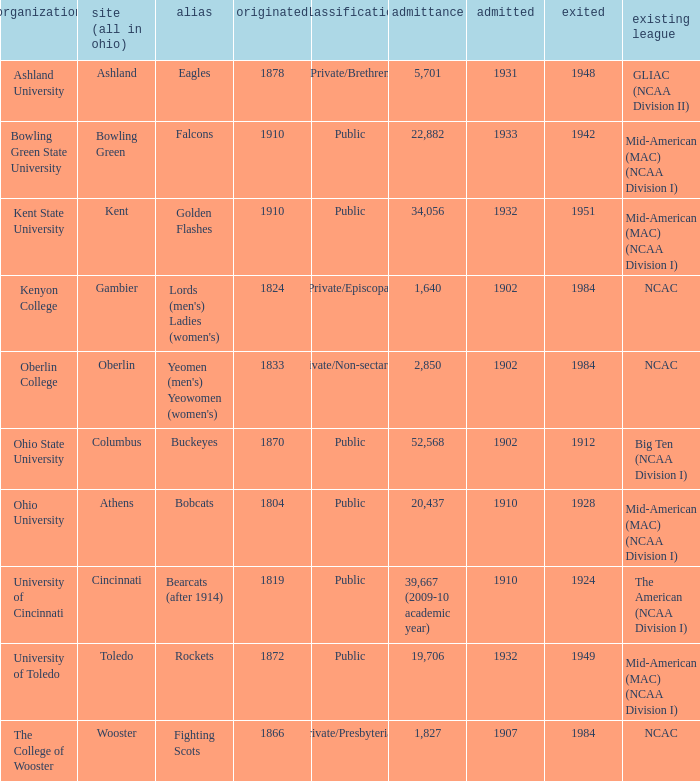Could you parse the entire table? {'header': ['organization', 'site (all in ohio)', 'alias', 'originated', 'classification', 'admittance', 'admitted', 'exited', 'existing league'], 'rows': [['Ashland University', 'Ashland', 'Eagles', '1878', 'Private/Brethren', '5,701', '1931', '1948', 'GLIAC (NCAA Division II)'], ['Bowling Green State University', 'Bowling Green', 'Falcons', '1910', 'Public', '22,882', '1933', '1942', 'Mid-American (MAC) (NCAA Division I)'], ['Kent State University', 'Kent', 'Golden Flashes', '1910', 'Public', '34,056', '1932', '1951', 'Mid-American (MAC) (NCAA Division I)'], ['Kenyon College', 'Gambier', "Lords (men's) Ladies (women's)", '1824', 'Private/Episcopal', '1,640', '1902', '1984', 'NCAC'], ['Oberlin College', 'Oberlin', "Yeomen (men's) Yeowomen (women's)", '1833', 'Private/Non-sectarian', '2,850', '1902', '1984', 'NCAC'], ['Ohio State University', 'Columbus', 'Buckeyes', '1870', 'Public', '52,568', '1902', '1912', 'Big Ten (NCAA Division I)'], ['Ohio University', 'Athens', 'Bobcats', '1804', 'Public', '20,437', '1910', '1928', 'Mid-American (MAC) (NCAA Division I)'], ['University of Cincinnati', 'Cincinnati', 'Bearcats (after 1914)', '1819', 'Public', '39,667 (2009-10 academic year)', '1910', '1924', 'The American (NCAA Division I)'], ['University of Toledo', 'Toledo', 'Rockets', '1872', 'Public', '19,706', '1932', '1949', 'Mid-American (MAC) (NCAA Division I)'], ['The College of Wooster', 'Wooster', 'Fighting Scots', '1866', 'Private/Presbyterian', '1,827', '1907', '1984', 'NCAC']]} Which year did enrolled Gambier members leave? 1984.0. 